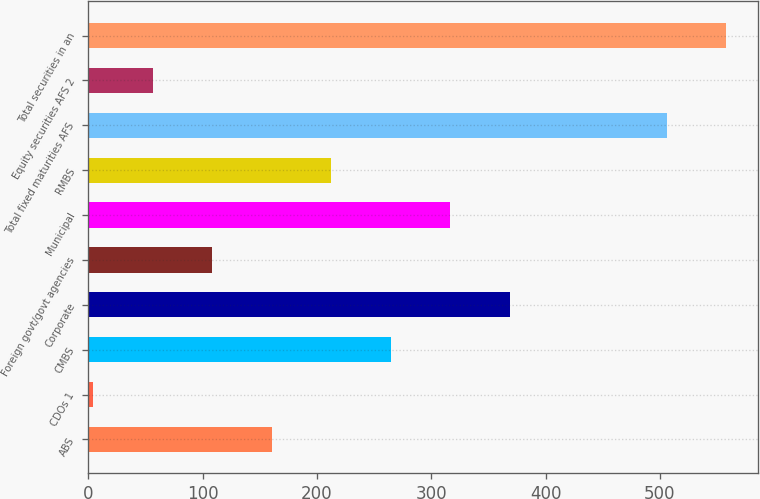Convert chart to OTSL. <chart><loc_0><loc_0><loc_500><loc_500><bar_chart><fcel>ABS<fcel>CDOs 1<fcel>CMBS<fcel>Corporate<fcel>Foreign govt/govt agencies<fcel>Municipal<fcel>RMBS<fcel>Total fixed maturities AFS<fcel>Equity securities AFS 2<fcel>Total securities in an<nl><fcel>160.3<fcel>4<fcel>264.5<fcel>368.7<fcel>108.2<fcel>316.6<fcel>212.4<fcel>506<fcel>56.1<fcel>558.1<nl></chart> 